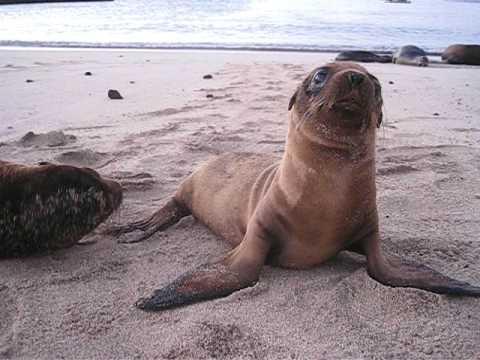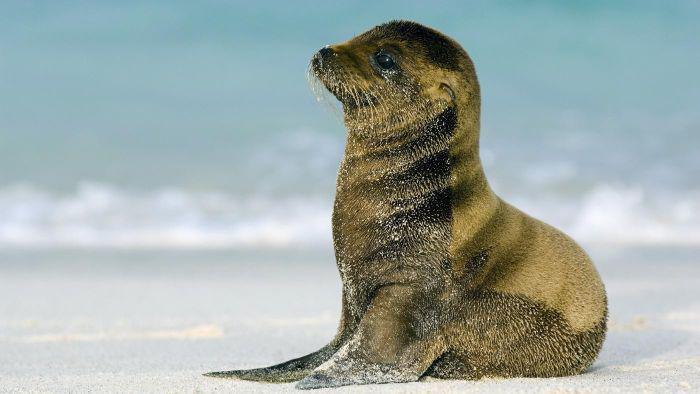The first image is the image on the left, the second image is the image on the right. Considering the images on both sides, is "In one image there is a lone seal pup looking towards the left of the image." valid? Answer yes or no. Yes. The first image is the image on the left, the second image is the image on the right. Analyze the images presented: Is the assertion "A lone seal sits and looks to the left of the image." valid? Answer yes or no. Yes. 